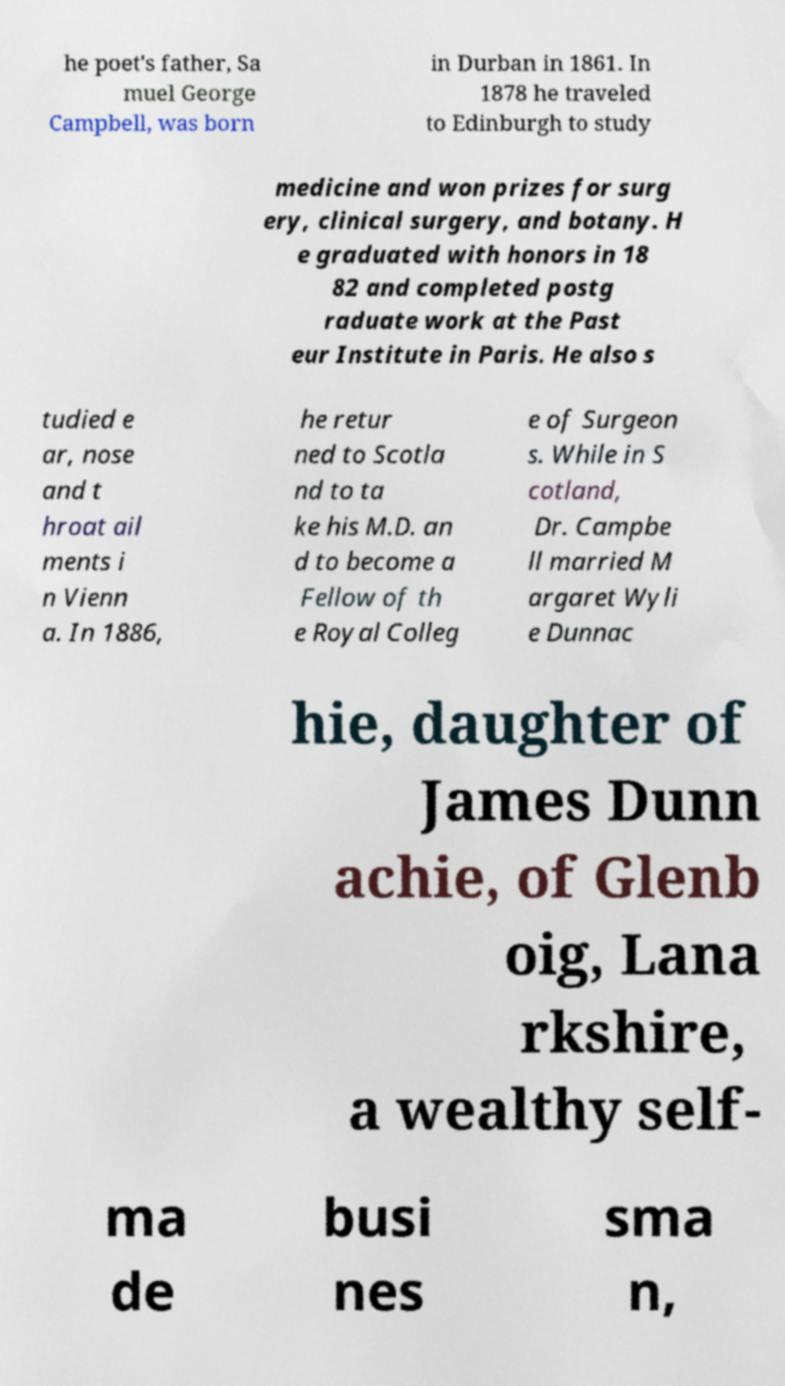What messages or text are displayed in this image? I need them in a readable, typed format. he poet's father, Sa muel George Campbell, was born in Durban in 1861. In 1878 he traveled to Edinburgh to study medicine and won prizes for surg ery, clinical surgery, and botany. H e graduated with honors in 18 82 and completed postg raduate work at the Past eur Institute in Paris. He also s tudied e ar, nose and t hroat ail ments i n Vienn a. In 1886, he retur ned to Scotla nd to ta ke his M.D. an d to become a Fellow of th e Royal Colleg e of Surgeon s. While in S cotland, Dr. Campbe ll married M argaret Wyli e Dunnac hie, daughter of James Dunn achie, of Glenb oig, Lana rkshire, a wealthy self- ma de busi nes sma n, 